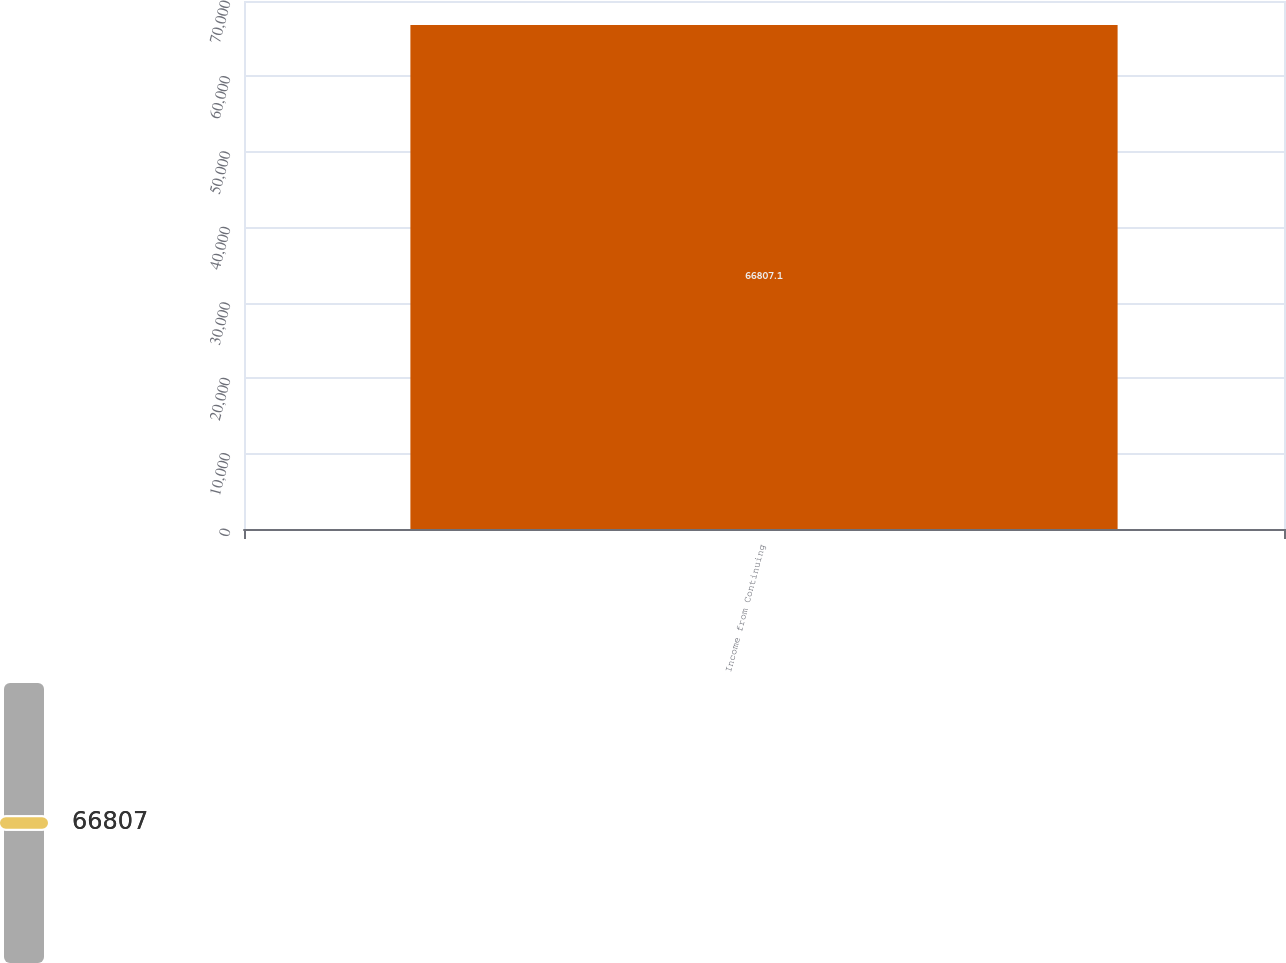Convert chart to OTSL. <chart><loc_0><loc_0><loc_500><loc_500><bar_chart><fcel>Income from Continuing<nl><fcel>66807.1<nl></chart> 